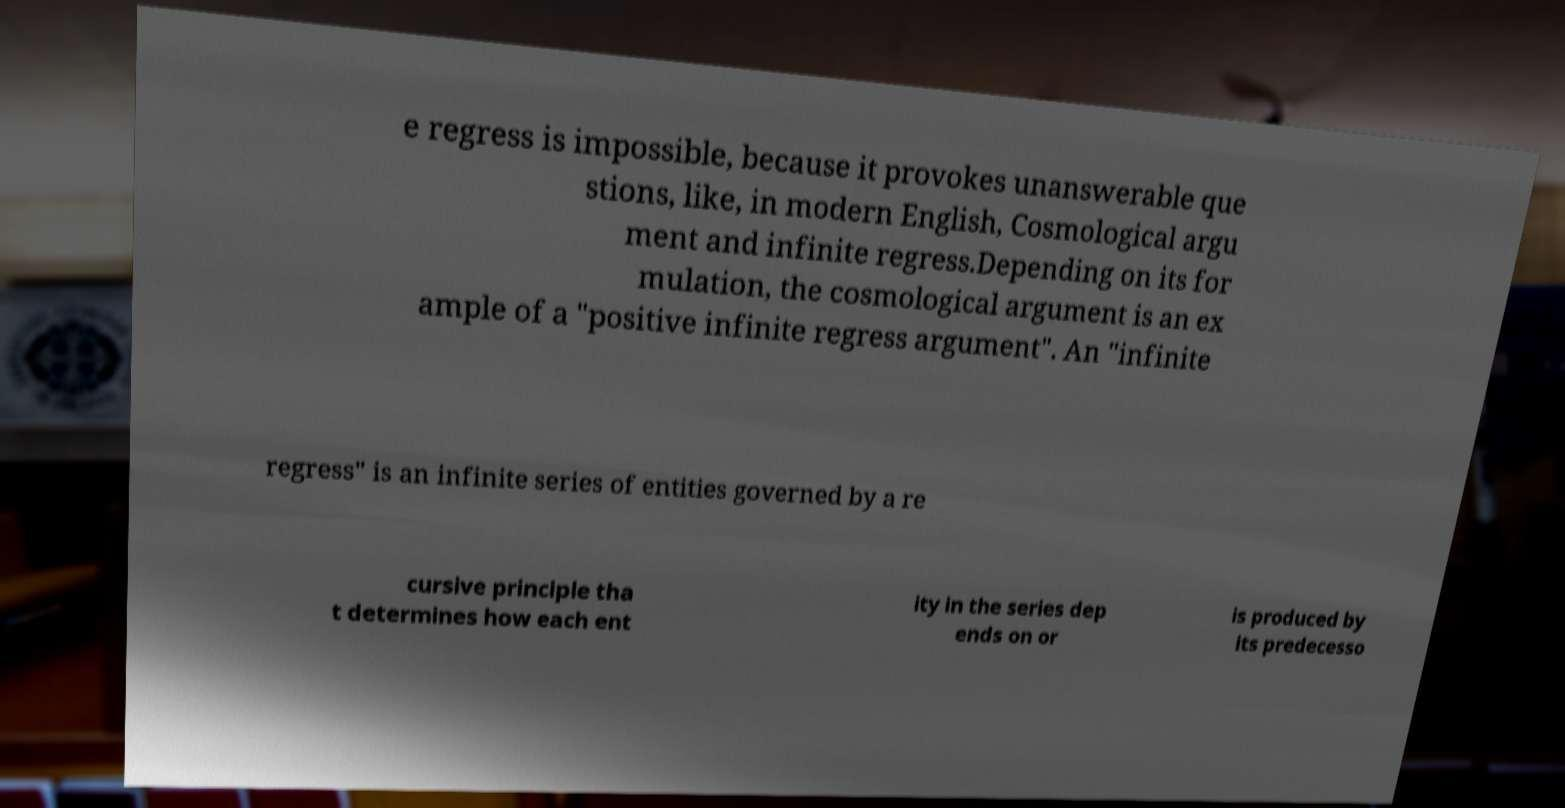There's text embedded in this image that I need extracted. Can you transcribe it verbatim? e regress is impossible, because it provokes unanswerable que stions, like, in modern English, Cosmological argu ment and infinite regress.Depending on its for mulation, the cosmological argument is an ex ample of a "positive infinite regress argument". An "infinite regress" is an infinite series of entities governed by a re cursive principle tha t determines how each ent ity in the series dep ends on or is produced by its predecesso 